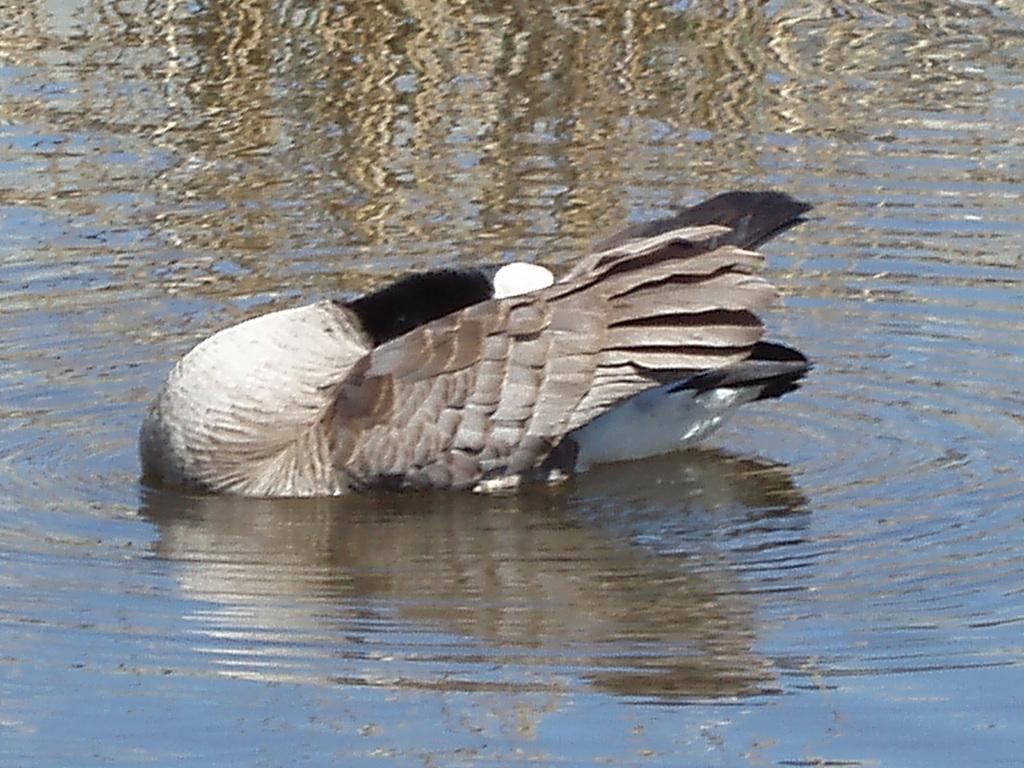What type of animal is in the image? There is a duck in the image. What colors can be seen on the duck? The duck has white, black, and gray coloring. Where is the duck located in the image? The duck is in the water. What type of gold object is floating next to the duck in the image? There is no gold object present in the image; it only features a duck in the water. 